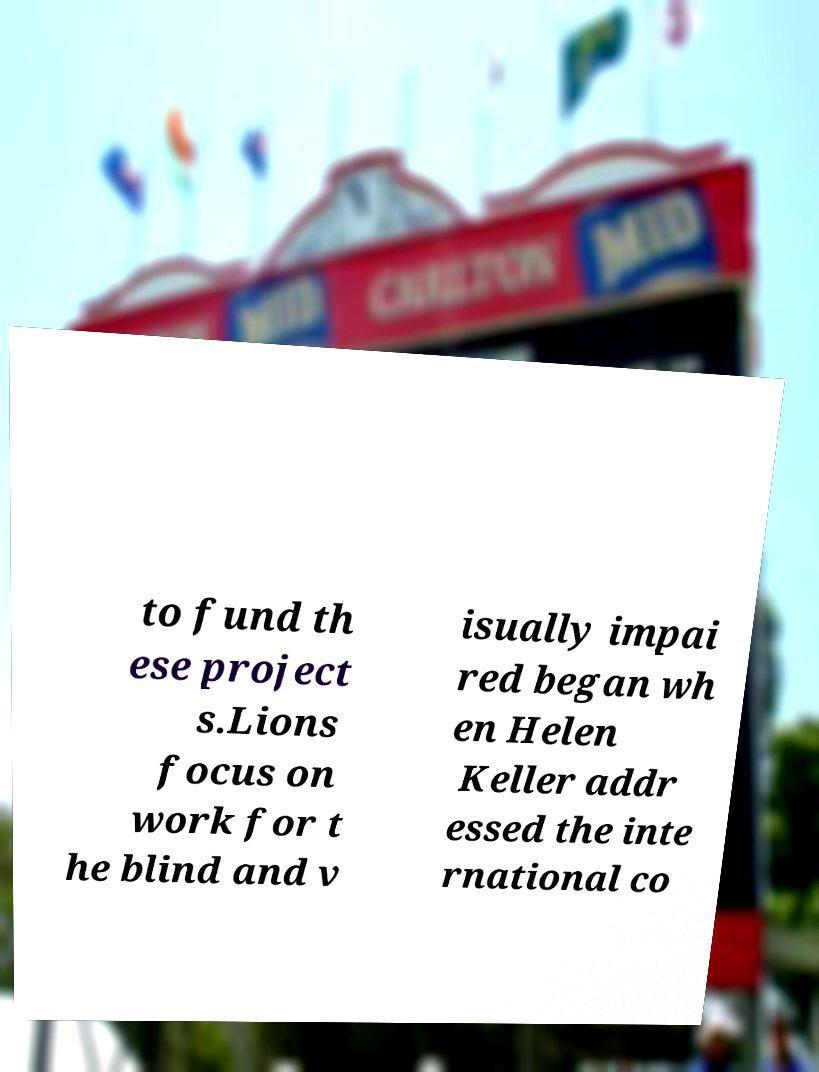I need the written content from this picture converted into text. Can you do that? to fund th ese project s.Lions focus on work for t he blind and v isually impai red began wh en Helen Keller addr essed the inte rnational co 